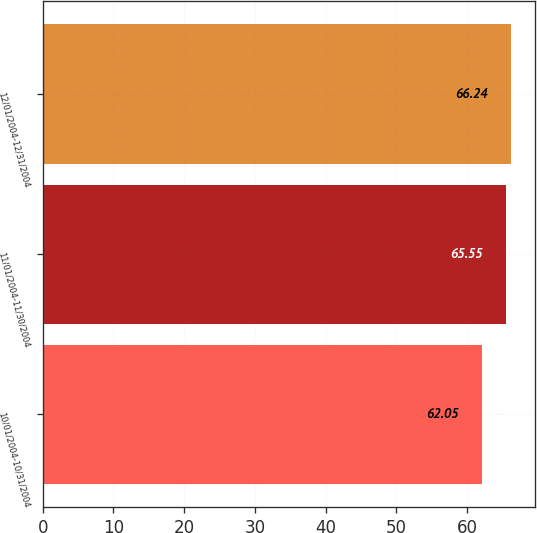Convert chart. <chart><loc_0><loc_0><loc_500><loc_500><bar_chart><fcel>10/01/2004-10/31/2004<fcel>11/01/2004-11/30/2004<fcel>12/01/2004-12/31/2004<nl><fcel>62.05<fcel>65.55<fcel>66.24<nl></chart> 